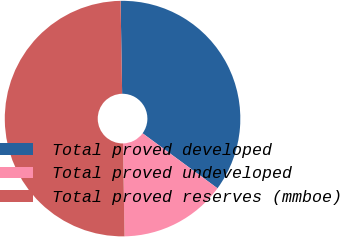Convert chart to OTSL. <chart><loc_0><loc_0><loc_500><loc_500><pie_chart><fcel>Total proved developed<fcel>Total proved undeveloped<fcel>Total proved reserves (mmboe)<nl><fcel>35.35%<fcel>14.65%<fcel>50.0%<nl></chart> 